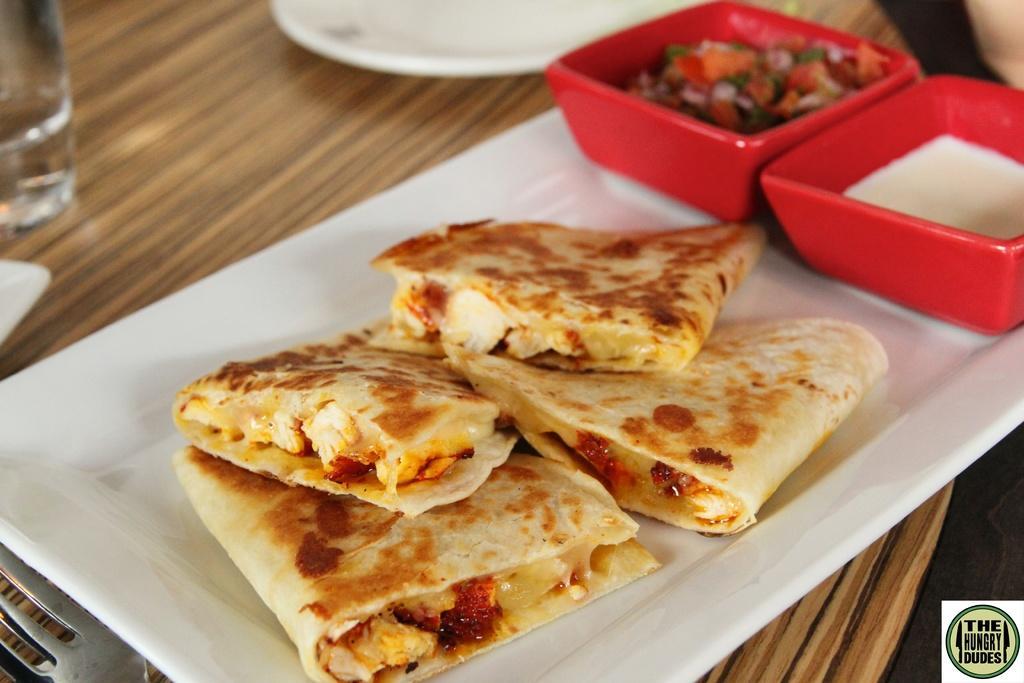Please provide a concise description of this image. We can see tray,food,bowls,plate,glass and fork on the wooden surface. 